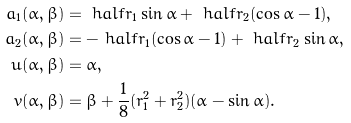Convert formula to latex. <formula><loc_0><loc_0><loc_500><loc_500>a _ { 1 } ( \alpha , \beta ) & = \ h a l f r _ { 1 } \sin \alpha + \ h a l f r _ { 2 } ( \cos \alpha - 1 ) , \\ a _ { 2 } ( \alpha , \beta ) & = - \ h a l f r _ { 1 } ( \cos \alpha - 1 ) + \ h a l f r _ { 2 } \sin \alpha , \\ u ( \alpha , \beta ) & = \alpha , \\ v ( \alpha , \beta ) & = \beta + { \frac { 1 } { 8 } } ( r _ { 1 } ^ { 2 } + r _ { 2 } ^ { 2 } ) ( \alpha - \sin \alpha ) .</formula> 